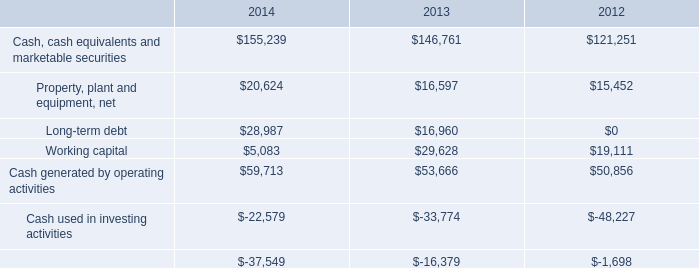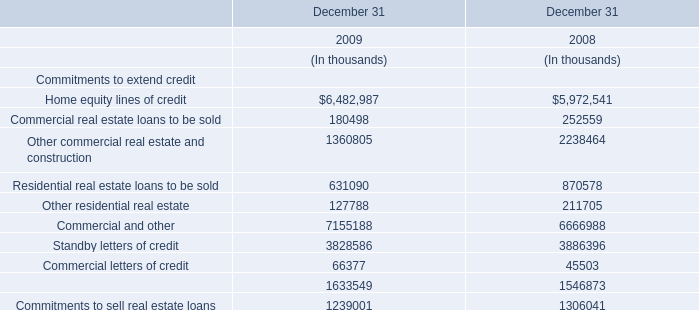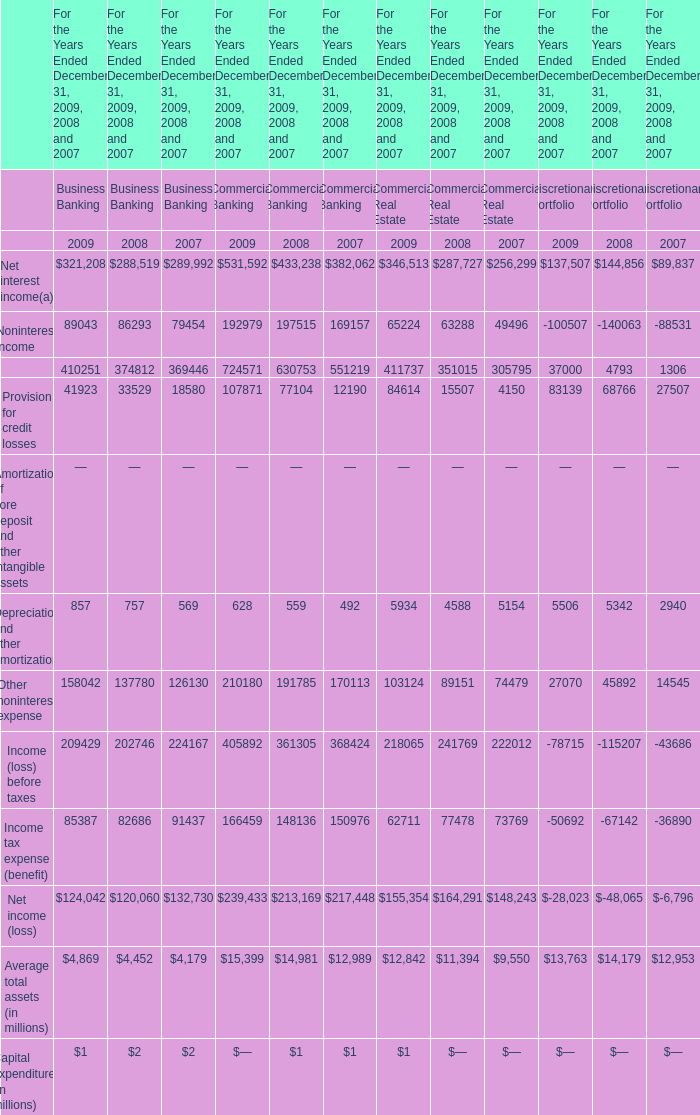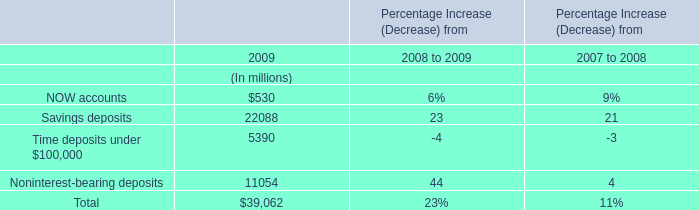What is the total value of the Noninterest income, the Depreciation and other amortization, the Other noninterest expense and the Net income in 2008 for Commercial Banking? 
Computations: (((197515 + 559) + 191785) + 213169)
Answer: 603028.0. 